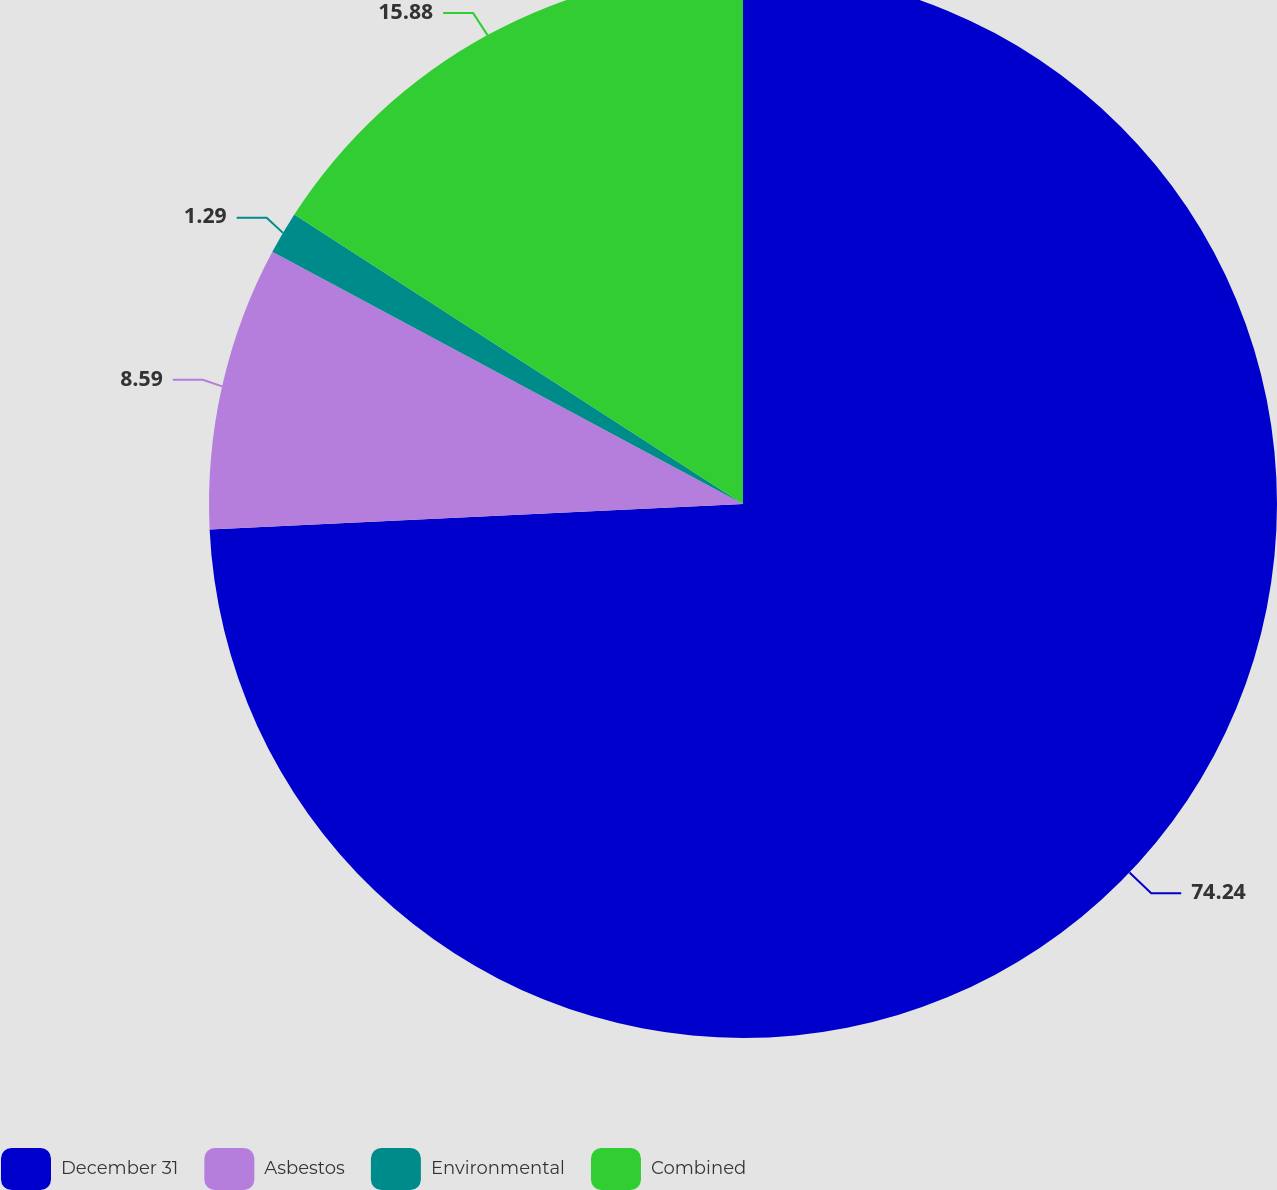Convert chart. <chart><loc_0><loc_0><loc_500><loc_500><pie_chart><fcel>December 31<fcel>Asbestos<fcel>Environmental<fcel>Combined<nl><fcel>74.24%<fcel>8.59%<fcel>1.29%<fcel>15.88%<nl></chart> 